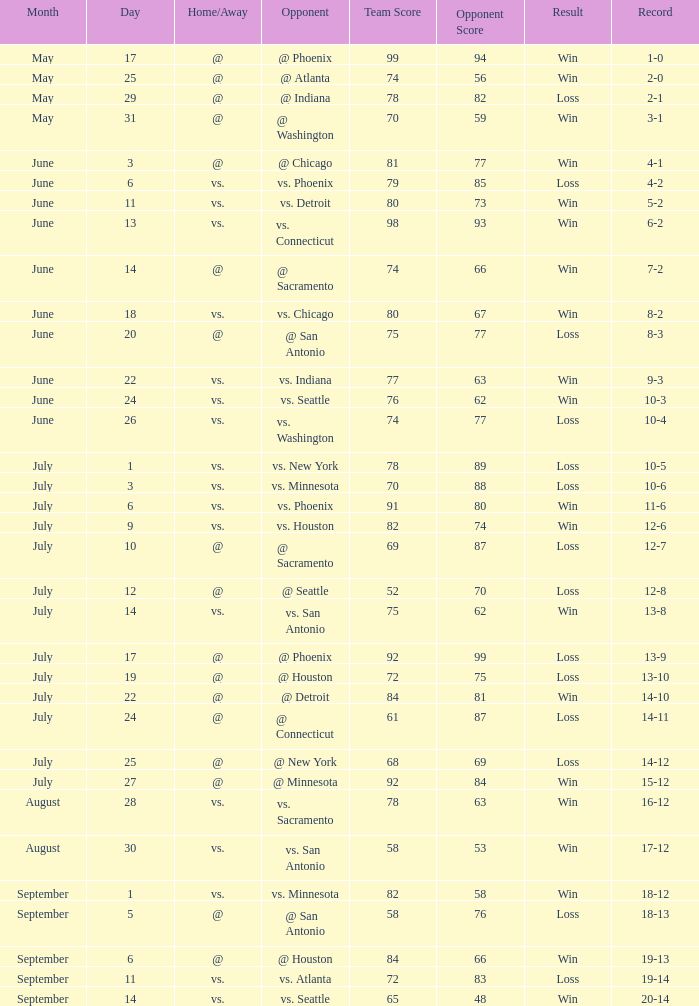What is the Score of the game @ San Antonio on June 20? 75-77. 